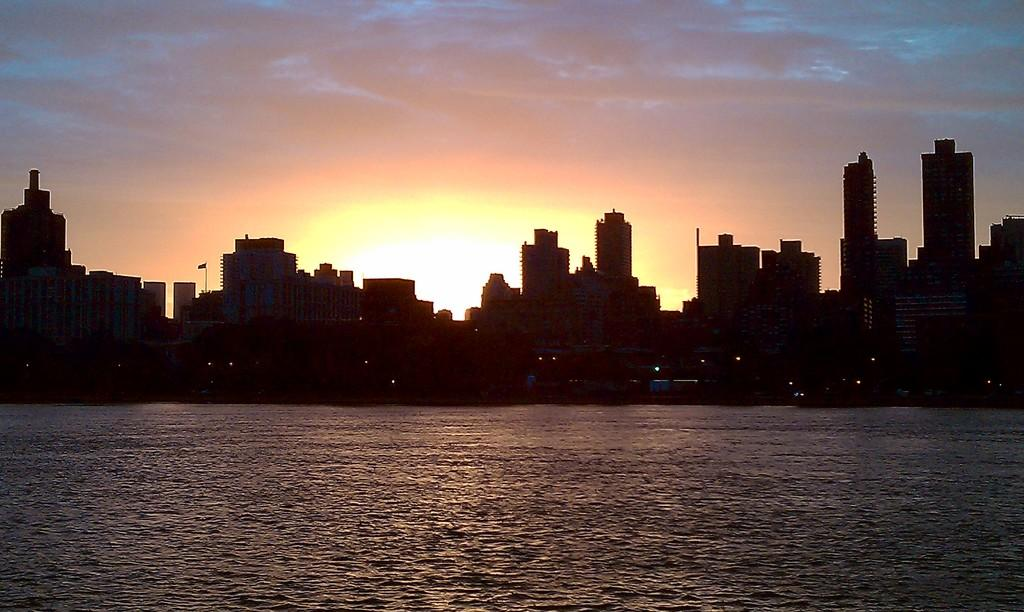What natural feature is present in the image? There is a river in the picture. What type of structures can be seen in the background? There are buildings in the background of the picture. What is the condition of the sky in the image? The sky is clear in the picture. What time of day is depicted in the image? There is a sunrise visible in the picture, indicating that it is early morning. What type of acoustics can be heard in the image? There is no sound present in the image, so it is not possible to determine the type of acoustics. What type of business is being conducted in the image? The image does not depict any business activities or transactions, so it is not possible to determine the type of business being conducted. 